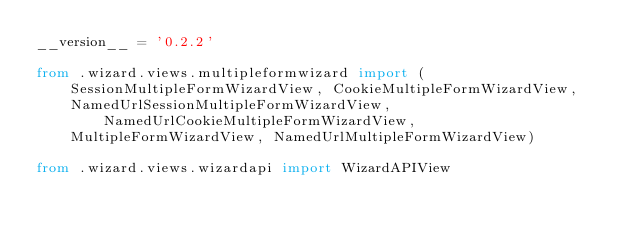Convert code to text. <code><loc_0><loc_0><loc_500><loc_500><_Python_>__version__ = '0.2.2'

from .wizard.views.multipleformwizard import (
    SessionMultipleFormWizardView, CookieMultipleFormWizardView,
    NamedUrlSessionMultipleFormWizardView, NamedUrlCookieMultipleFormWizardView,
    MultipleFormWizardView, NamedUrlMultipleFormWizardView)

from .wizard.views.wizardapi import WizardAPIView
</code> 